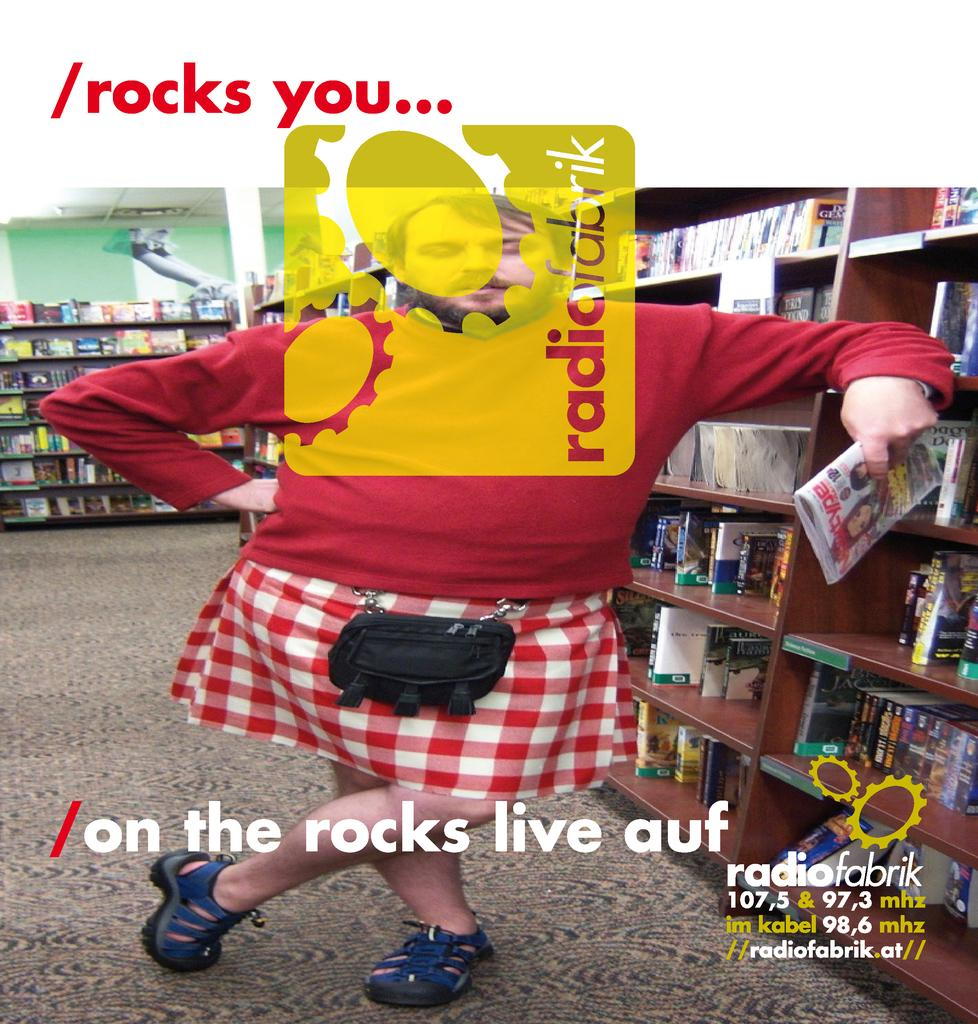What is the gender of the person in the image? The person in the image is a man. What is the man standing on? The man is standing on the floor. What color is the man's T-shirt? The man is wearing a red color T-shirt. What type of clothing is the man wearing that is typically associated with women? The man is wearing a skirt. What is the man holding in his left hand? The man is holding a book in his left hand. What type of furniture is present in the image? There are wooden shelves in the image. What items can be seen on the wooden shelves? There are books on the wooden shelves. Can you see a dog sitting next to the man in the image? There is no dog present in the image. What reason does the man give for wearing a skirt in the image? The image does not provide any information about the man's reason for wearing a skirt. 